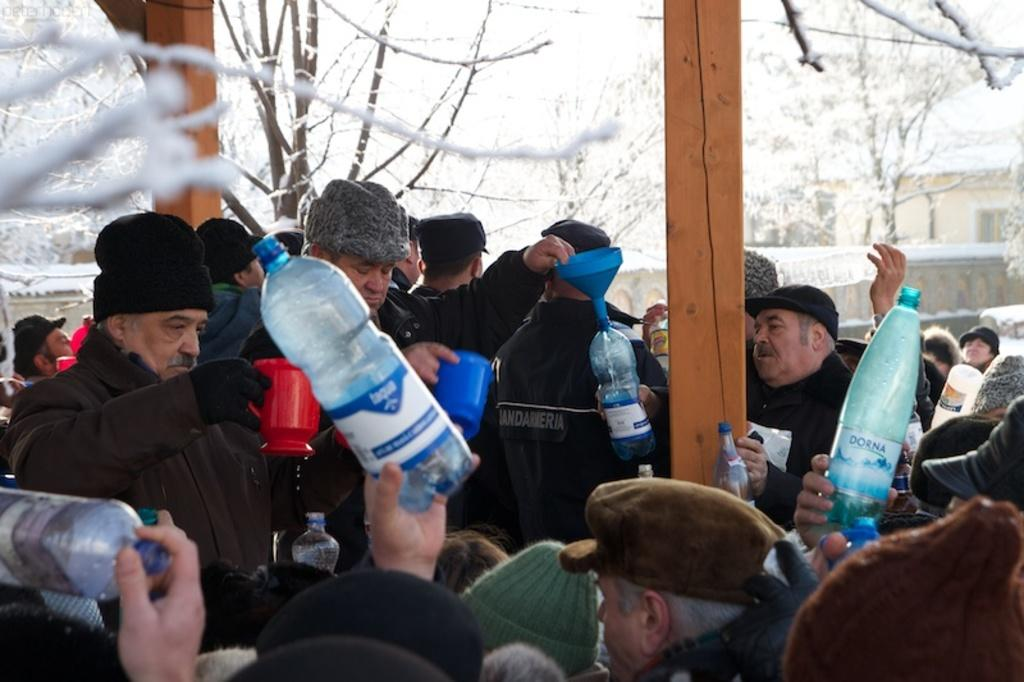Who or what is present in the image? There are people in the image. What are the people holding in their hands? The people are holding mugs and bottles. What is the condition of the trees in the image? The trees in the image are covered with snow. Reasoning: Let' Let's think step by step in order to produce the conversation. We start by identifying the main subjects in the image, which are the people. Then, we describe what the people are doing or holding, which are mugs and bottles. Finally, we focus on the environment or setting of the image, which is the snow-covered trees. Each question is designed to elicit a specific detail about the image that is known from the provided facts. Absurd Question/Answer: What type of root can be seen growing from the mug in the image? There is no root growing from the mug in the image; it is a mug holding a beverage. 